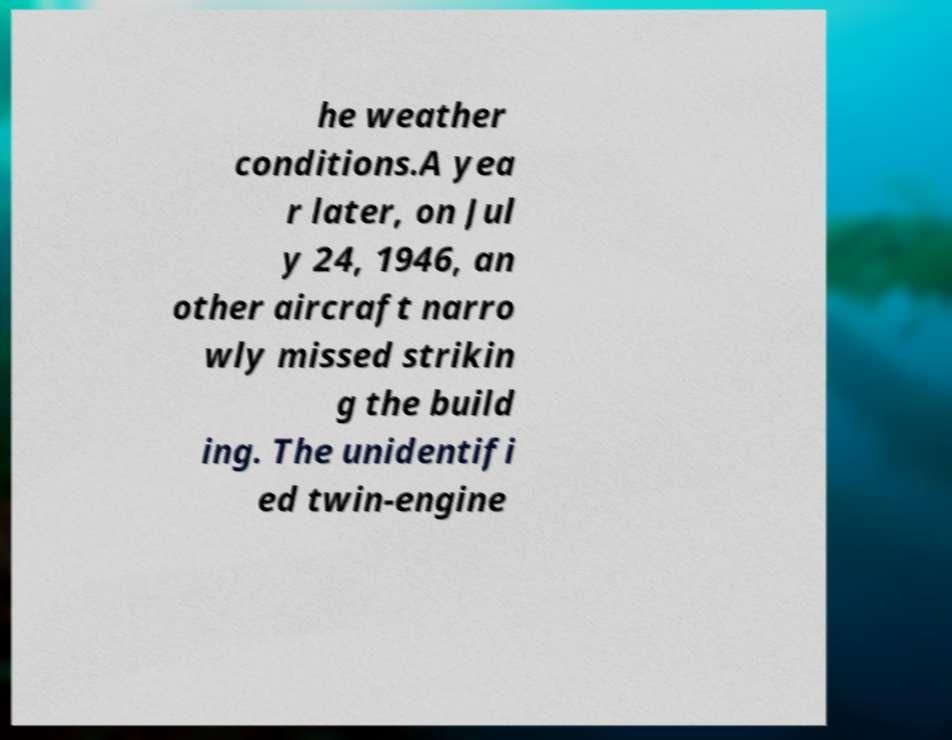Please identify and transcribe the text found in this image. he weather conditions.A yea r later, on Jul y 24, 1946, an other aircraft narro wly missed strikin g the build ing. The unidentifi ed twin-engine 